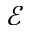<formula> <loc_0><loc_0><loc_500><loc_500>\mathcal { E }</formula> 